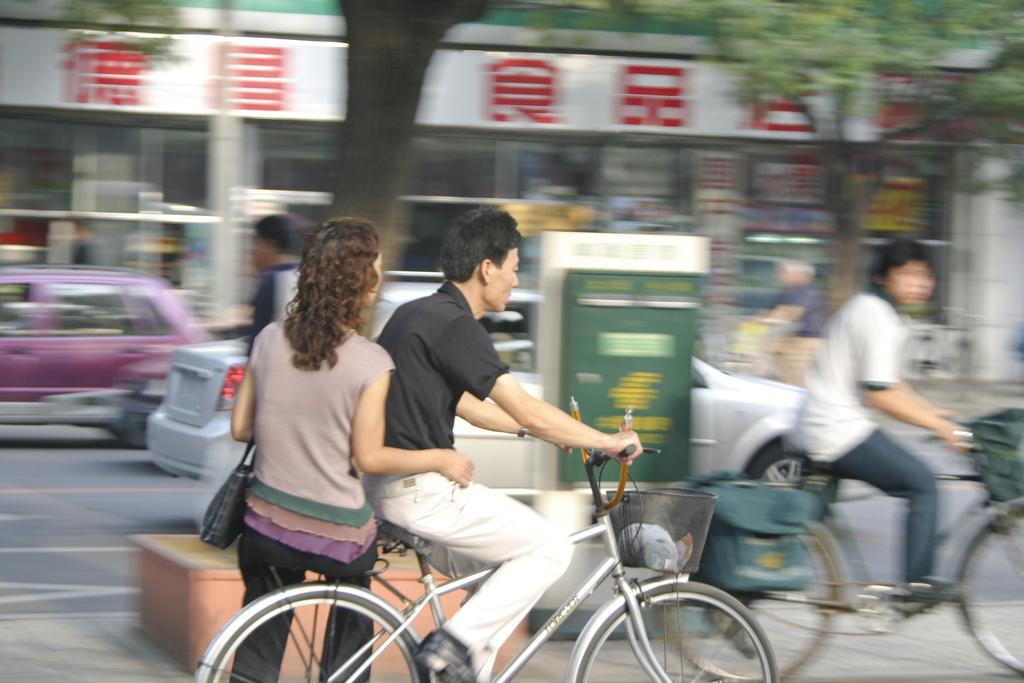Describe this image in one or two sentences. In this image we can see this persons are sitting on the bicycle and riding on the road. In the background we can see cars, trees and building. 